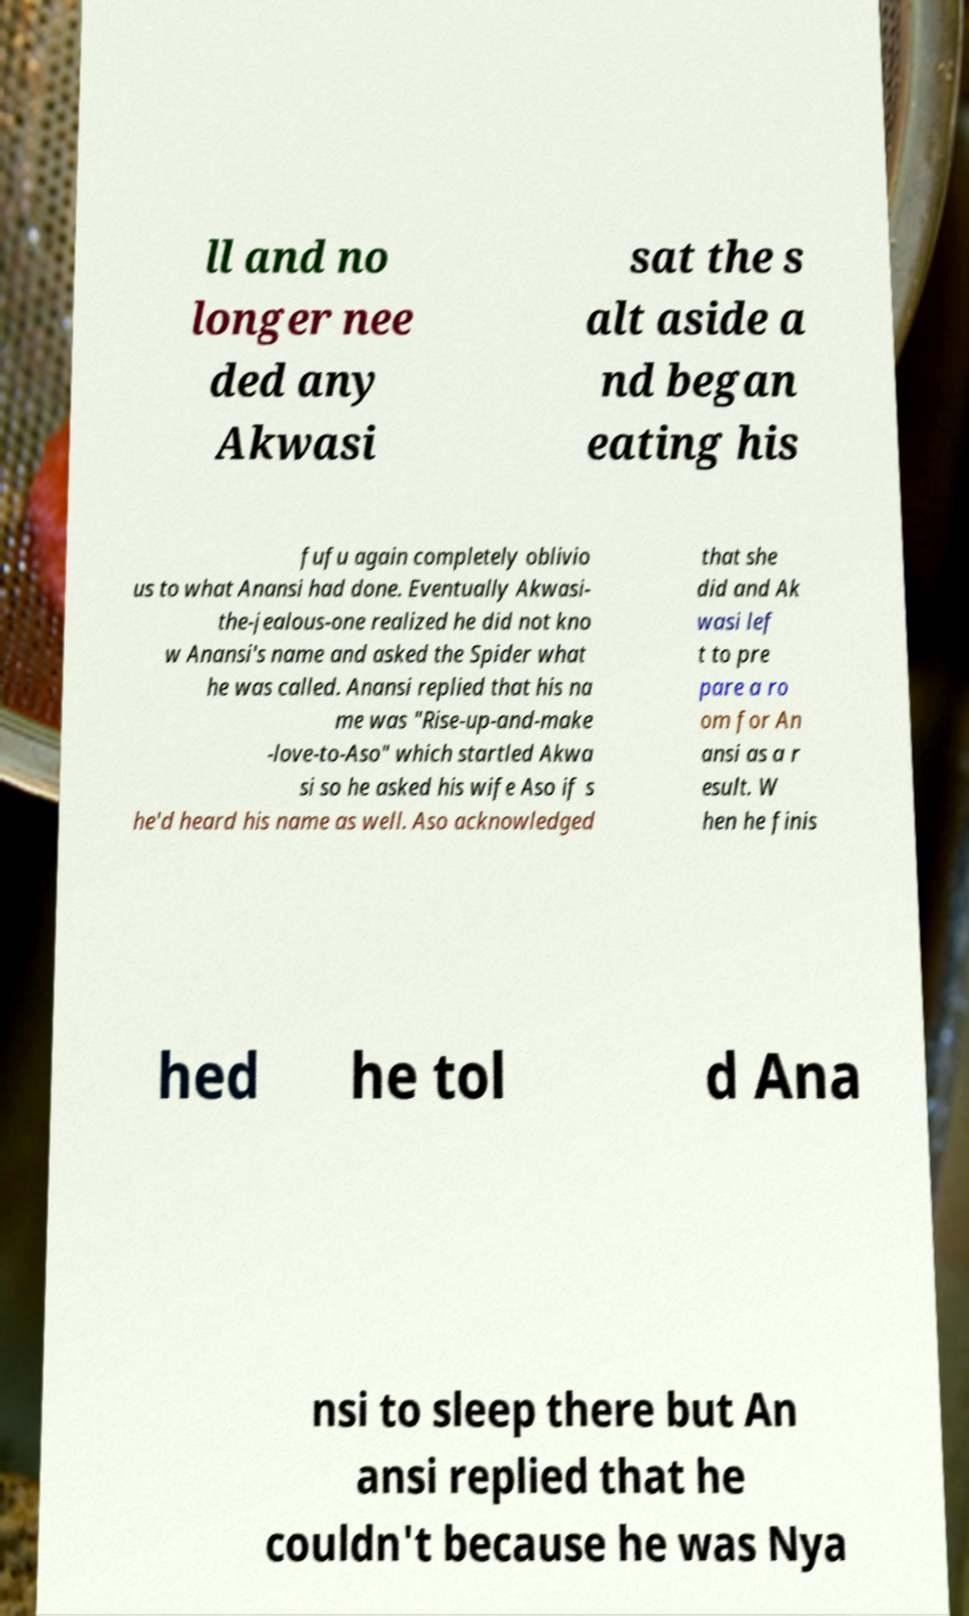I need the written content from this picture converted into text. Can you do that? ll and no longer nee ded any Akwasi sat the s alt aside a nd began eating his fufu again completely oblivio us to what Anansi had done. Eventually Akwasi- the-jealous-one realized he did not kno w Anansi's name and asked the Spider what he was called. Anansi replied that his na me was "Rise-up-and-make -love-to-Aso" which startled Akwa si so he asked his wife Aso if s he'd heard his name as well. Aso acknowledged that she did and Ak wasi lef t to pre pare a ro om for An ansi as a r esult. W hen he finis hed he tol d Ana nsi to sleep there but An ansi replied that he couldn't because he was Nya 